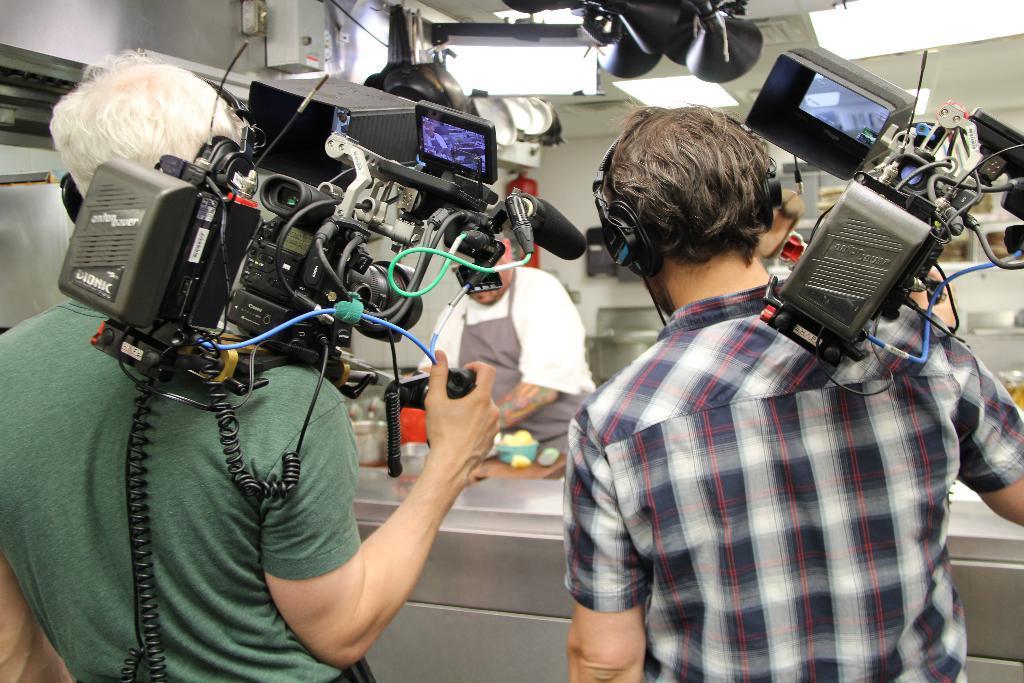Please provide a concise description of this image. In the foreground two men are holding cameras in the hands and standing facing towards the back side. In the background there is a person standing in front of the table. On the table, I can see some objects. In the background there is a wall. At the top there is a black color object. 